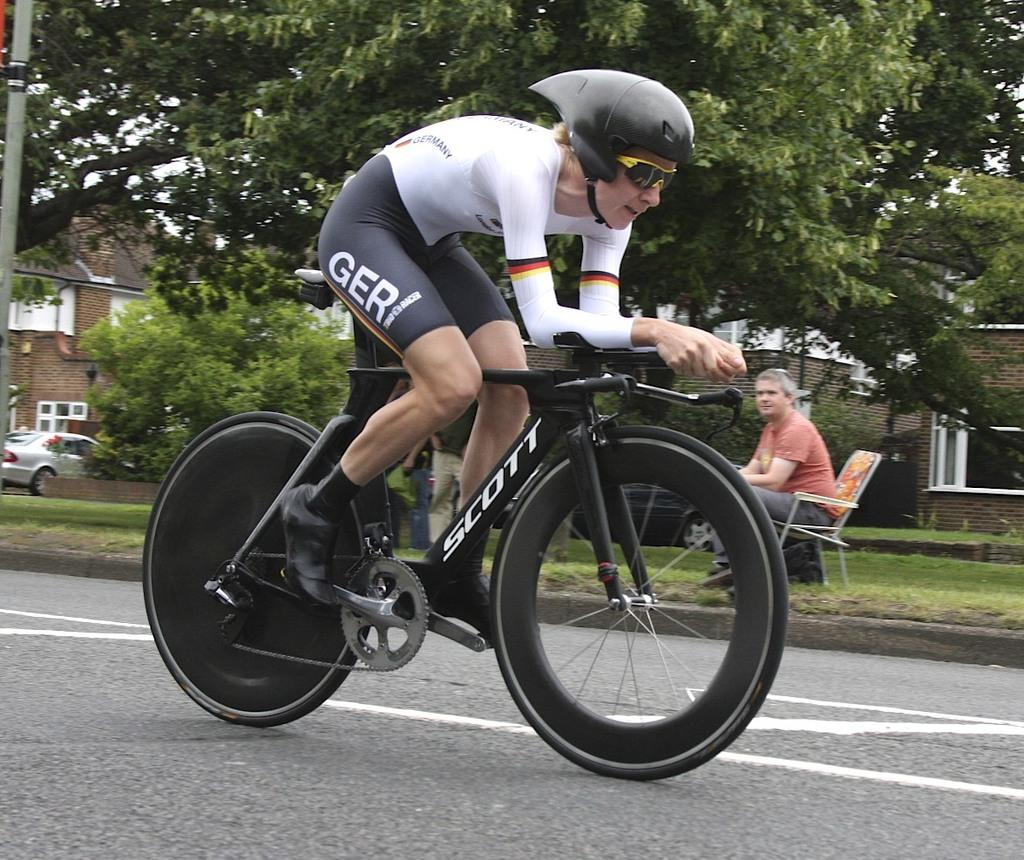What is the main subject of the image? The main subject of the image is a person riding a bicycle. Is there anyone else present in the image? Yes, there is another person sitting beside the cyclist in the image. What type of jeans is the bat wearing in the image? There is no bat or jeans present in the image. 